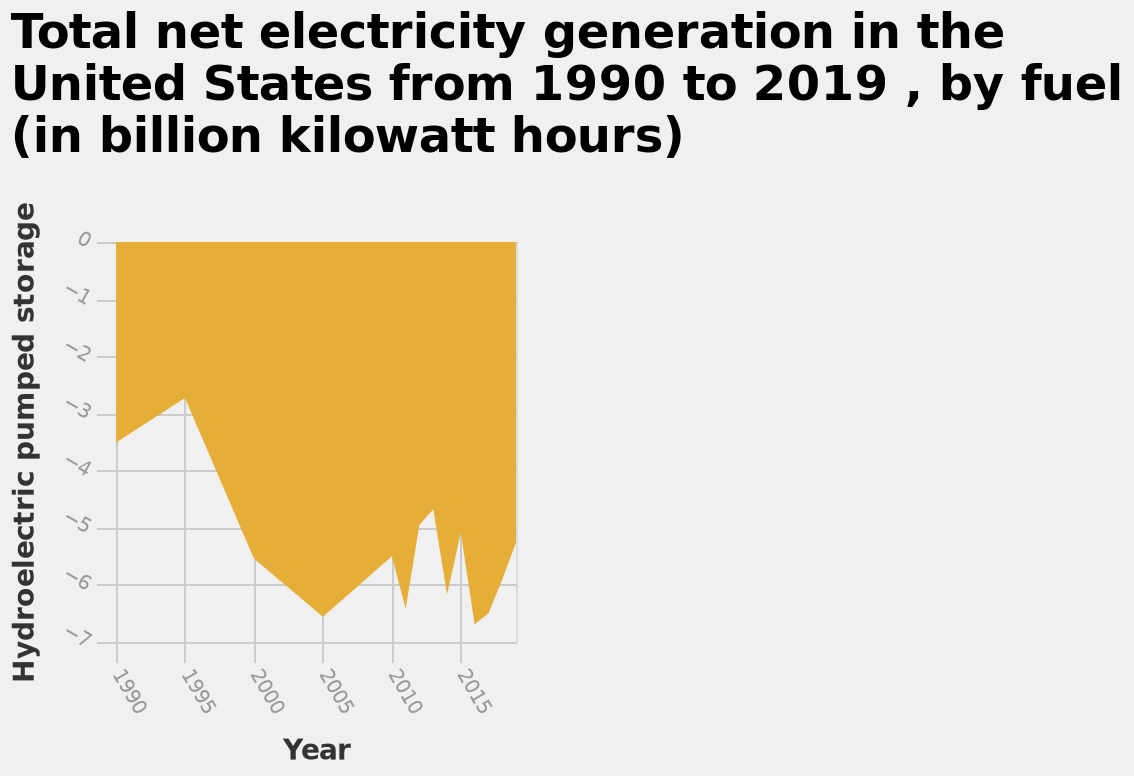<image>
What is the label on the y-axis in the area graph?  The y-axis in the area graph is labeled "Hydroelectric pumped storage" with a categorical scale ranging from -7 to 0. What is being represented by the area graph?  The area graph represents the total net electricity generation in the United States from 1990 to 2019, categorized by fuel, in billion kilowatt hours. Is the x-axis in the bar graph labeled "Hydroelectric pumped storage" with a categorical scale ranging from -7 to 0? No. The y-axis in the area graph is labeled "Hydroelectric pumped storage" with a categorical scale ranging from -7 to 0. 